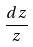Convert formula to latex. <formula><loc_0><loc_0><loc_500><loc_500>\frac { d z } { z }</formula> 